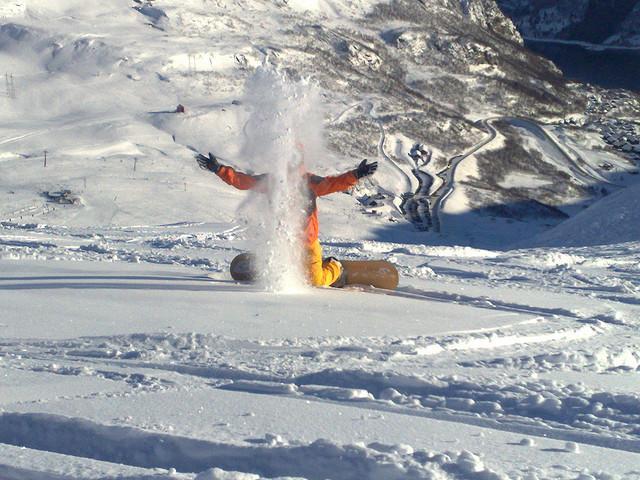How many people are in the picture?
Give a very brief answer. 1. 